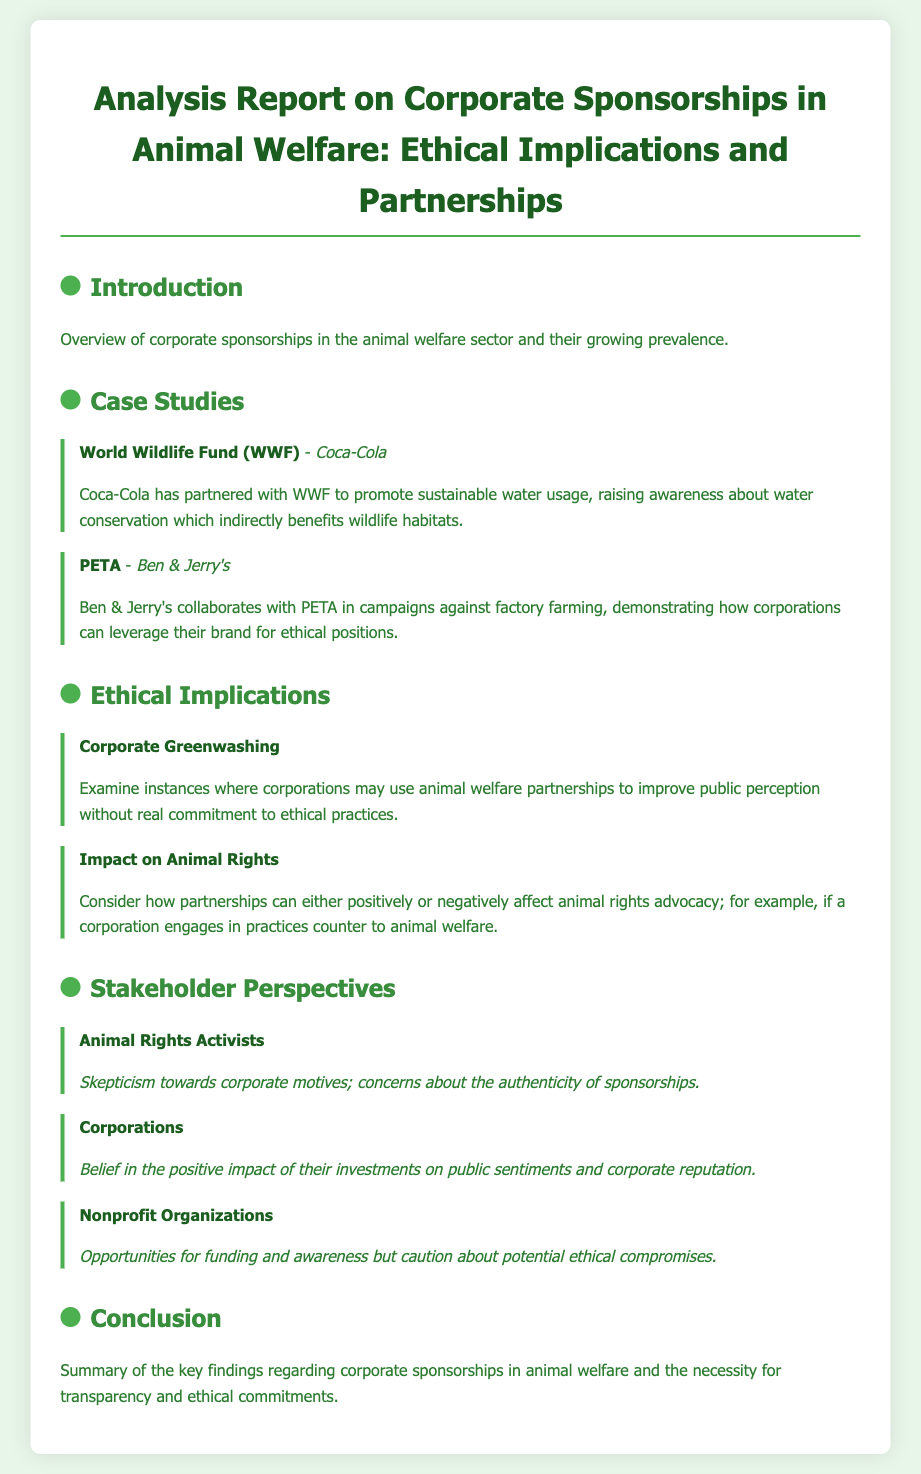What is the title of the report? The title of the report is given in the document's header, which describes the content and focus of the analysis.
Answer: Analysis Report on Corporate Sponsorships in Animal Welfare: Ethical Implications and Partnerships Who is the corporate partner of World Wildlife Fund? This information is specified in a case study section outlining partnerships between organizations and corporations.
Answer: Coca-Cola What aspect is examined under ethical implications related to corporate sponsorships? This is mentioned in the ethical implications section, highlighting concerns over corporate practices.
Answer: Corporate Greenwashing What do animal rights activists express towards corporate motives? The viewpoint of animal rights activists is detailed in the stakeholder perspectives section, reflecting their skepticism.
Answer: Skepticism towards corporate motives Which organization collaborates with Ben & Jerry's? This information appears in the case studies section, detailing partnerships that support animal welfare campaigns.
Answer: PETA 